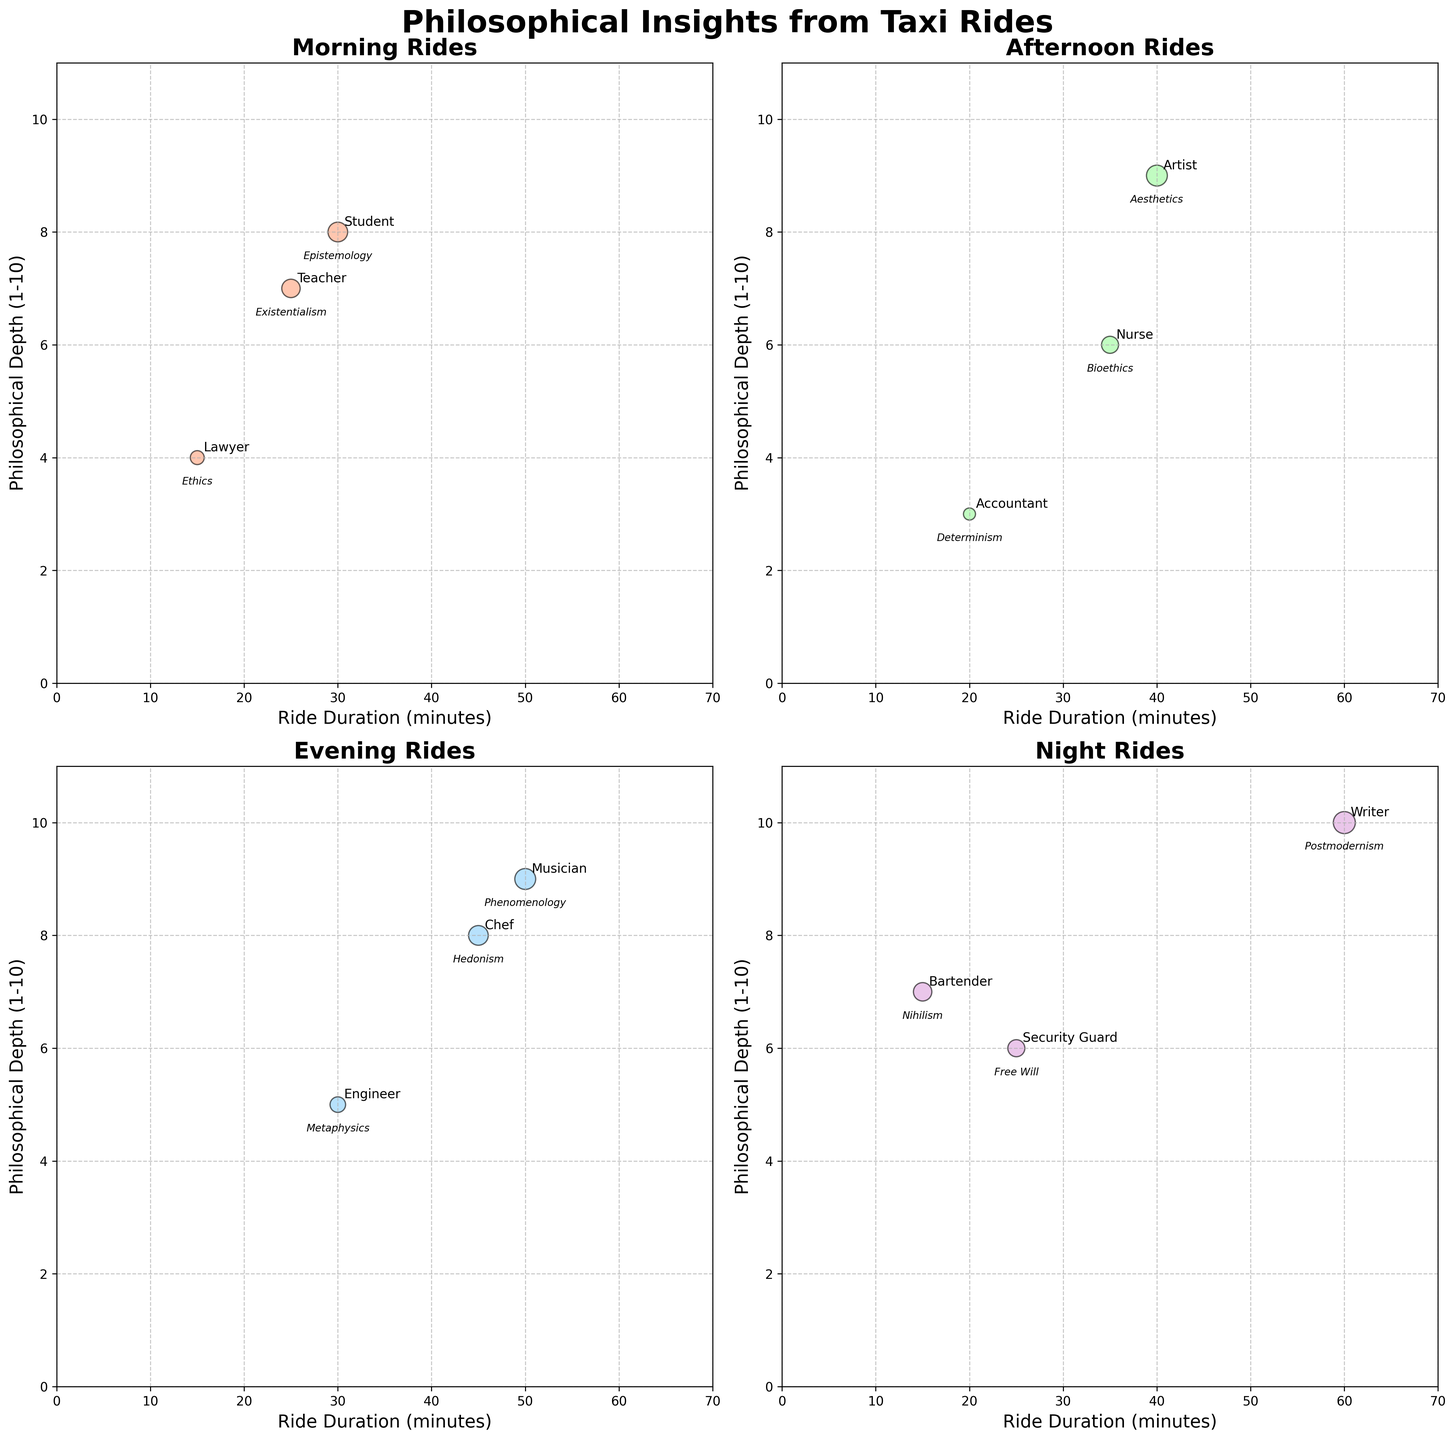How many passengers are shown for each time of day? The figure is divided into four subplots, each representing a different time of day (Morning, Afternoon, Evening, Night). Count the number of bubbles in each subplot to determine the number of passengers. Morning: 3, Afternoon: 3, Evening: 3, Night: 3
Answer: 3 Which time of day had the longest ride duration overall? Examine the x-axis of each subplot, which indicates the ride duration in minutes. The longest ride duration overall is the highest value across all subplots. The night subplot shows a ride duration of 60 minutes.
Answer: Night What's the correlation between ride duration and philosophical depth for the morning rides? Look at the morning subplot. Identify the general trend that relates ride duration (x-axis) to philosophical depth (y-axis). As the ride duration increases (from 15 to 30 minutes), the philosophical depth also increases (from 4 to 8).
Answer: Positive Who had the deepest philosophical conversation in the evening? In the evening subplot, identify the highest point on the y-axis, representing the greatest depth in philosophical conversation. The musician had a depth of 9.
Answer: Musician Which passenger occupation had the shortest ride duration in the dataset? Observe the x-axis for each subplot and identify the smallest ride duration value. The shortest ride duration is 15 minutes in Morning (Lawyer) and Night (Bartender).
Answer: Lawyer, Bartender Compare the philosophical depth between the teacher and the accountant. Who had a deeper conversation? Locate the teacher in the morning subplot and the accountant in the afternoon subplot. Compare their y-axis values. The teacher had a depth of 7, while the accountant had a depth of 3.
Answer: Teacher How did the nurse's conversation depth compare to the other afternoon passengers? In the afternoon subplot, compare the nurse's y-axis value (6) against the artist (9) and the accountant (3). The nurse's conversation was deeper than the accountant's but shallower than the artist's.
Answer: In-between List the topics discussed during night rides and their respective depths. Look at the night subplot and note the annotated topics and their corresponding depths on the y-axis. Nihilism (7), Free Will (6), Postmodernism (10).
Answer: Nihilism: 7, Free Will: 6, Postmodernism: 10 Which time of day had the most variance in philosophical conversation depths? Compare the range of y-axis values in each subplot. The night subplot has the greatest variance with depths spanning from 6 to 10, while other subplots have a narrower range.
Answer: Night 